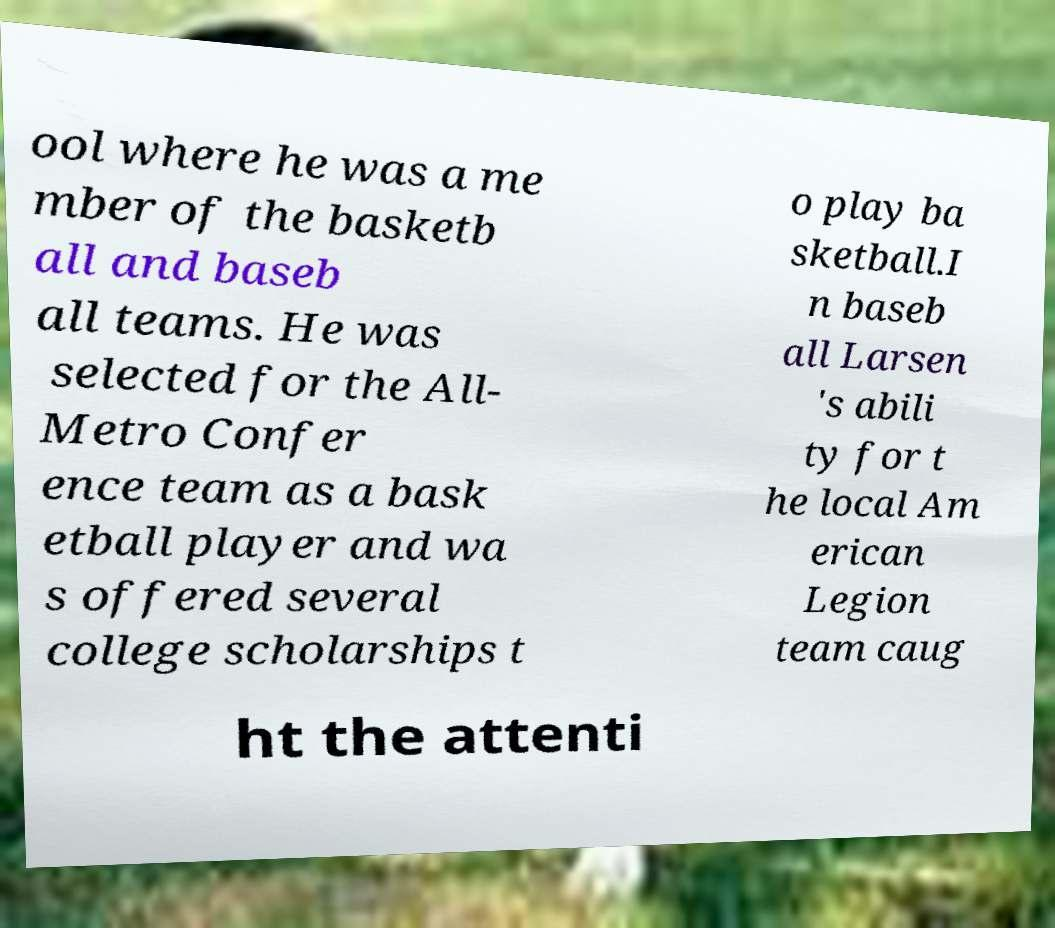Can you read and provide the text displayed in the image?This photo seems to have some interesting text. Can you extract and type it out for me? ool where he was a me mber of the basketb all and baseb all teams. He was selected for the All- Metro Confer ence team as a bask etball player and wa s offered several college scholarships t o play ba sketball.I n baseb all Larsen 's abili ty for t he local Am erican Legion team caug ht the attenti 